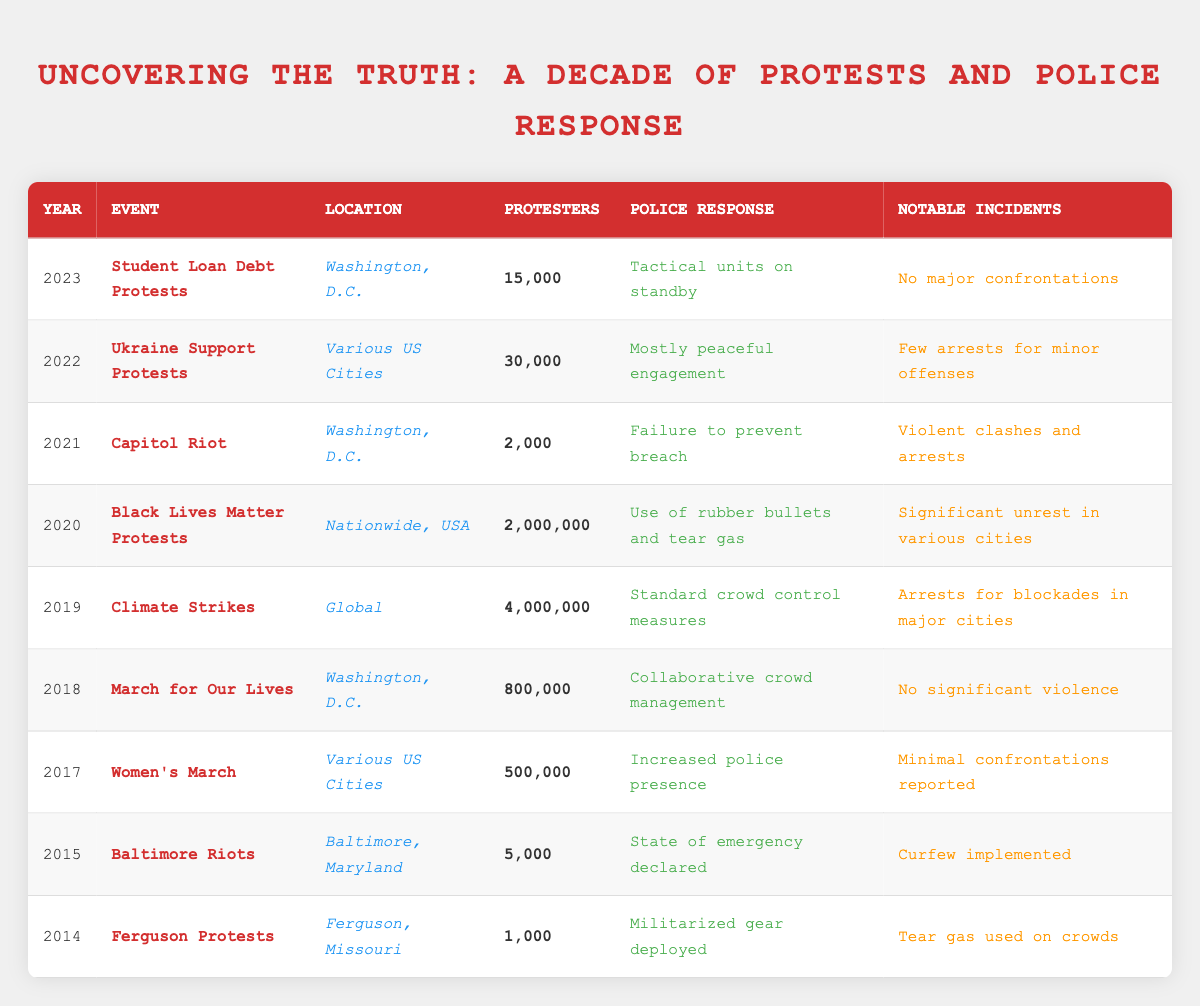What year did the largest number of protesters gather? The table shows that in 2019, during the Climate Strikes event, there were an estimated 4,000,000 protesters, which is the highest figure in the table.
Answer: 2019 What was the police response during the Black Lives Matter protests? According to the table, the police response during the Black Lives Matter Protests in 2020 was "Use of rubber bullets and tear gas."
Answer: Use of rubber bullets and tear gas How many more protesters were there in the Women's March compared to the Ferguson Protests? The Women's March had 500,000 protesters while the Ferguson Protests had 1,000 protesters. So, 500,000 - 1,000 = 499,000 more protesters in the Women's March.
Answer: 499,000 Was there any significant violence reported during the March for Our Lives? The table states that during the March for Our Lives in 2018, there was "No significant violence," indicating that the statement is true.
Answer: True What average number of protesters participated in the protests over the last decade? To find the average, sum the number of protesters (1,000 + 5,000 + 500,000 + 800,000 + 4,000,000 + 2,000,000 + 2,000 + 30,000 + 15,000 = 6,553,000) and divide by the number of events (9). Thus, the average is 6,553,000 / 9 = 728,111.11, rounded down gives about 728,111.
Answer: 728,111 Did the police response improve from the Ferguson Protests to the March for Our Lives? Comparing the police responses, the Ferguson Protests had "Militarized gear deployed," while the March for Our Lives had "Collaborative crowd management," indicating an improvement in approach.
Answer: Yes What notable incident occurred during the Capitol Riot? The table indicates that during the Capitol Riot in 2021, there were "Violent clashes and arrests," which is the notable incident listed.
Answer: Violent clashes and arrests Which protest had the least number of protesters? From the data presented, the Ferguson Protests in 2014 had the lowest estimate of protesters at 1,000.
Answer: 1,000 What was the notable incident during the Climate Strikes? The table reports that the notable incident during the Climate Strikes in 2019 was "Arrests for blockades in major cities."
Answer: Arrests for blockades in major cities Calculate the difference in the number of protesters between the Climate Strikes and the Student Loan Debt Protests. The Climate Strikes had 4,000,000 protesters and the Student Loan Debt Protests had 15,000. The difference is 4,000,000 - 15,000 = 3,985,000.
Answer: 3,985,000 What police response did the authorities take during the 2022 Ukraine Support Protests? The table shows that the police response during the 2022 Ukraine Support Protests was "Mostly peaceful engagement."
Answer: Mostly peaceful engagement 